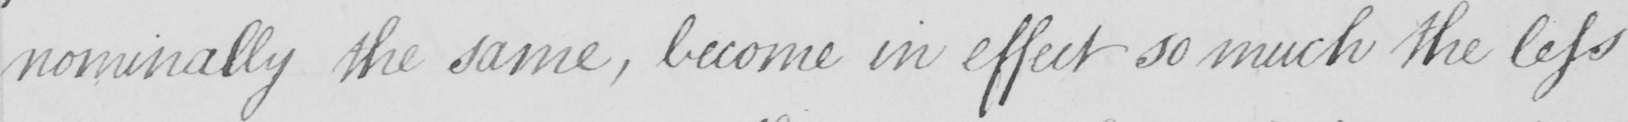Please transcribe the handwritten text in this image. nominally the same , become in effect so much the less 